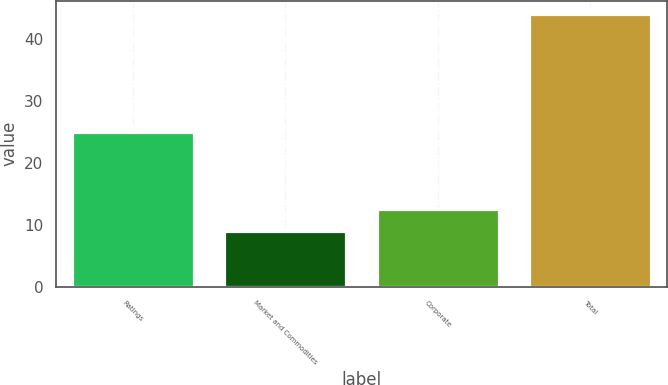Convert chart to OTSL. <chart><loc_0><loc_0><loc_500><loc_500><bar_chart><fcel>Ratings<fcel>Market and Commodities<fcel>Corporate<fcel>Total<nl><fcel>25<fcel>9<fcel>12.5<fcel>44<nl></chart> 